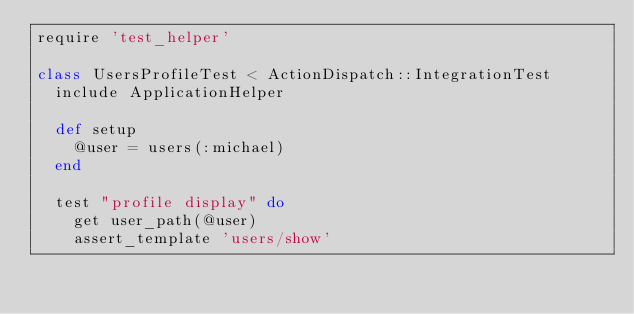Convert code to text. <code><loc_0><loc_0><loc_500><loc_500><_Ruby_>require 'test_helper'

class UsersProfileTest < ActionDispatch::IntegrationTest
  include ApplicationHelper
  
  def setup
    @user = users(:michael)
  end 
  
  test "profile display" do
    get user_path(@user)
    assert_template 'users/show'</code> 